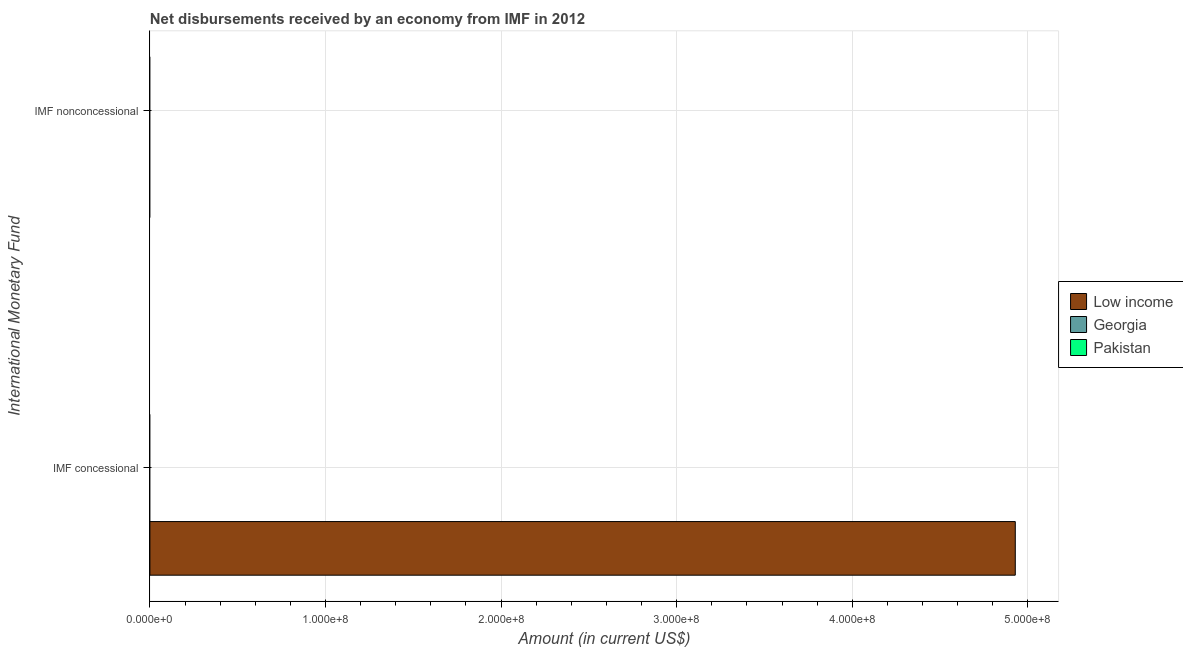Are the number of bars on each tick of the Y-axis equal?
Your answer should be compact. No. What is the label of the 1st group of bars from the top?
Offer a very short reply. IMF nonconcessional. Across all countries, what is the maximum net concessional disbursements from imf?
Your response must be concise. 4.93e+08. Across all countries, what is the minimum net non concessional disbursements from imf?
Keep it short and to the point. 0. What is the total net concessional disbursements from imf in the graph?
Your answer should be very brief. 4.93e+08. How many countries are there in the graph?
Offer a terse response. 3. Does the graph contain grids?
Offer a terse response. Yes. How many legend labels are there?
Provide a short and direct response. 3. How are the legend labels stacked?
Provide a short and direct response. Vertical. What is the title of the graph?
Your response must be concise. Net disbursements received by an economy from IMF in 2012. What is the label or title of the Y-axis?
Give a very brief answer. International Monetary Fund. What is the Amount (in current US$) of Low income in IMF concessional?
Your answer should be very brief. 4.93e+08. What is the Amount (in current US$) in Georgia in IMF concessional?
Provide a succinct answer. 0. What is the Amount (in current US$) of Pakistan in IMF concessional?
Your response must be concise. 0. What is the Amount (in current US$) in Low income in IMF nonconcessional?
Provide a succinct answer. 0. What is the Amount (in current US$) of Georgia in IMF nonconcessional?
Offer a very short reply. 0. Across all International Monetary Fund, what is the maximum Amount (in current US$) in Low income?
Offer a terse response. 4.93e+08. What is the total Amount (in current US$) in Low income in the graph?
Provide a succinct answer. 4.93e+08. What is the total Amount (in current US$) in Georgia in the graph?
Offer a very short reply. 0. What is the average Amount (in current US$) in Low income per International Monetary Fund?
Your answer should be very brief. 2.46e+08. What is the difference between the highest and the lowest Amount (in current US$) of Low income?
Keep it short and to the point. 4.93e+08. 